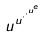<formula> <loc_0><loc_0><loc_500><loc_500>u ^ { u ^ { \cdot ^ { \cdot ^ { u ^ { e } } } } }</formula> 